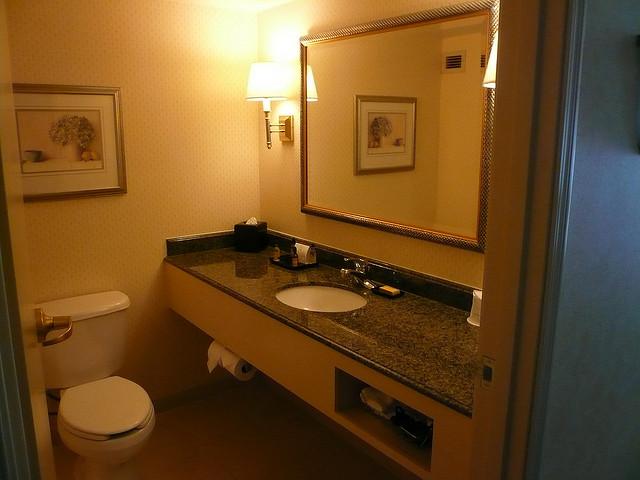How many light bulbs are there?
Quick response, please. 2. Is the style of this bathroom masculine?
Concise answer only. Yes. How many sinks are there?
Give a very brief answer. 1. How is taken the picture?
Write a very short answer. Camera. Do you see the doorknob in the mirror?
Keep it brief. No. How many lights are there?
Short answer required. 2. What room is this?
Keep it brief. Bathroom. What is reflected in the mirror?
Write a very short answer. Picture. 